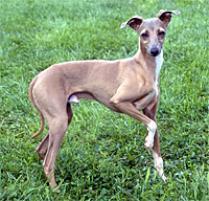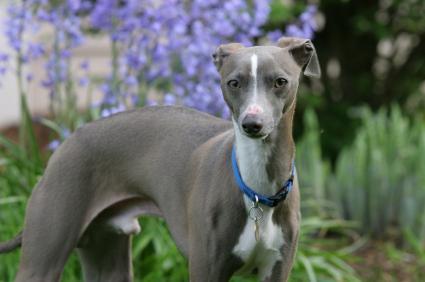The first image is the image on the left, the second image is the image on the right. Given the left and right images, does the statement "there is a gray dog standing with its body facing right" hold true? Answer yes or no. Yes. 